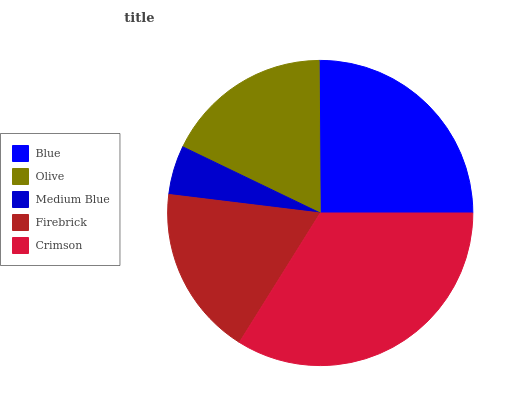Is Medium Blue the minimum?
Answer yes or no. Yes. Is Crimson the maximum?
Answer yes or no. Yes. Is Olive the minimum?
Answer yes or no. No. Is Olive the maximum?
Answer yes or no. No. Is Blue greater than Olive?
Answer yes or no. Yes. Is Olive less than Blue?
Answer yes or no. Yes. Is Olive greater than Blue?
Answer yes or no. No. Is Blue less than Olive?
Answer yes or no. No. Is Firebrick the high median?
Answer yes or no. Yes. Is Firebrick the low median?
Answer yes or no. Yes. Is Olive the high median?
Answer yes or no. No. Is Crimson the low median?
Answer yes or no. No. 